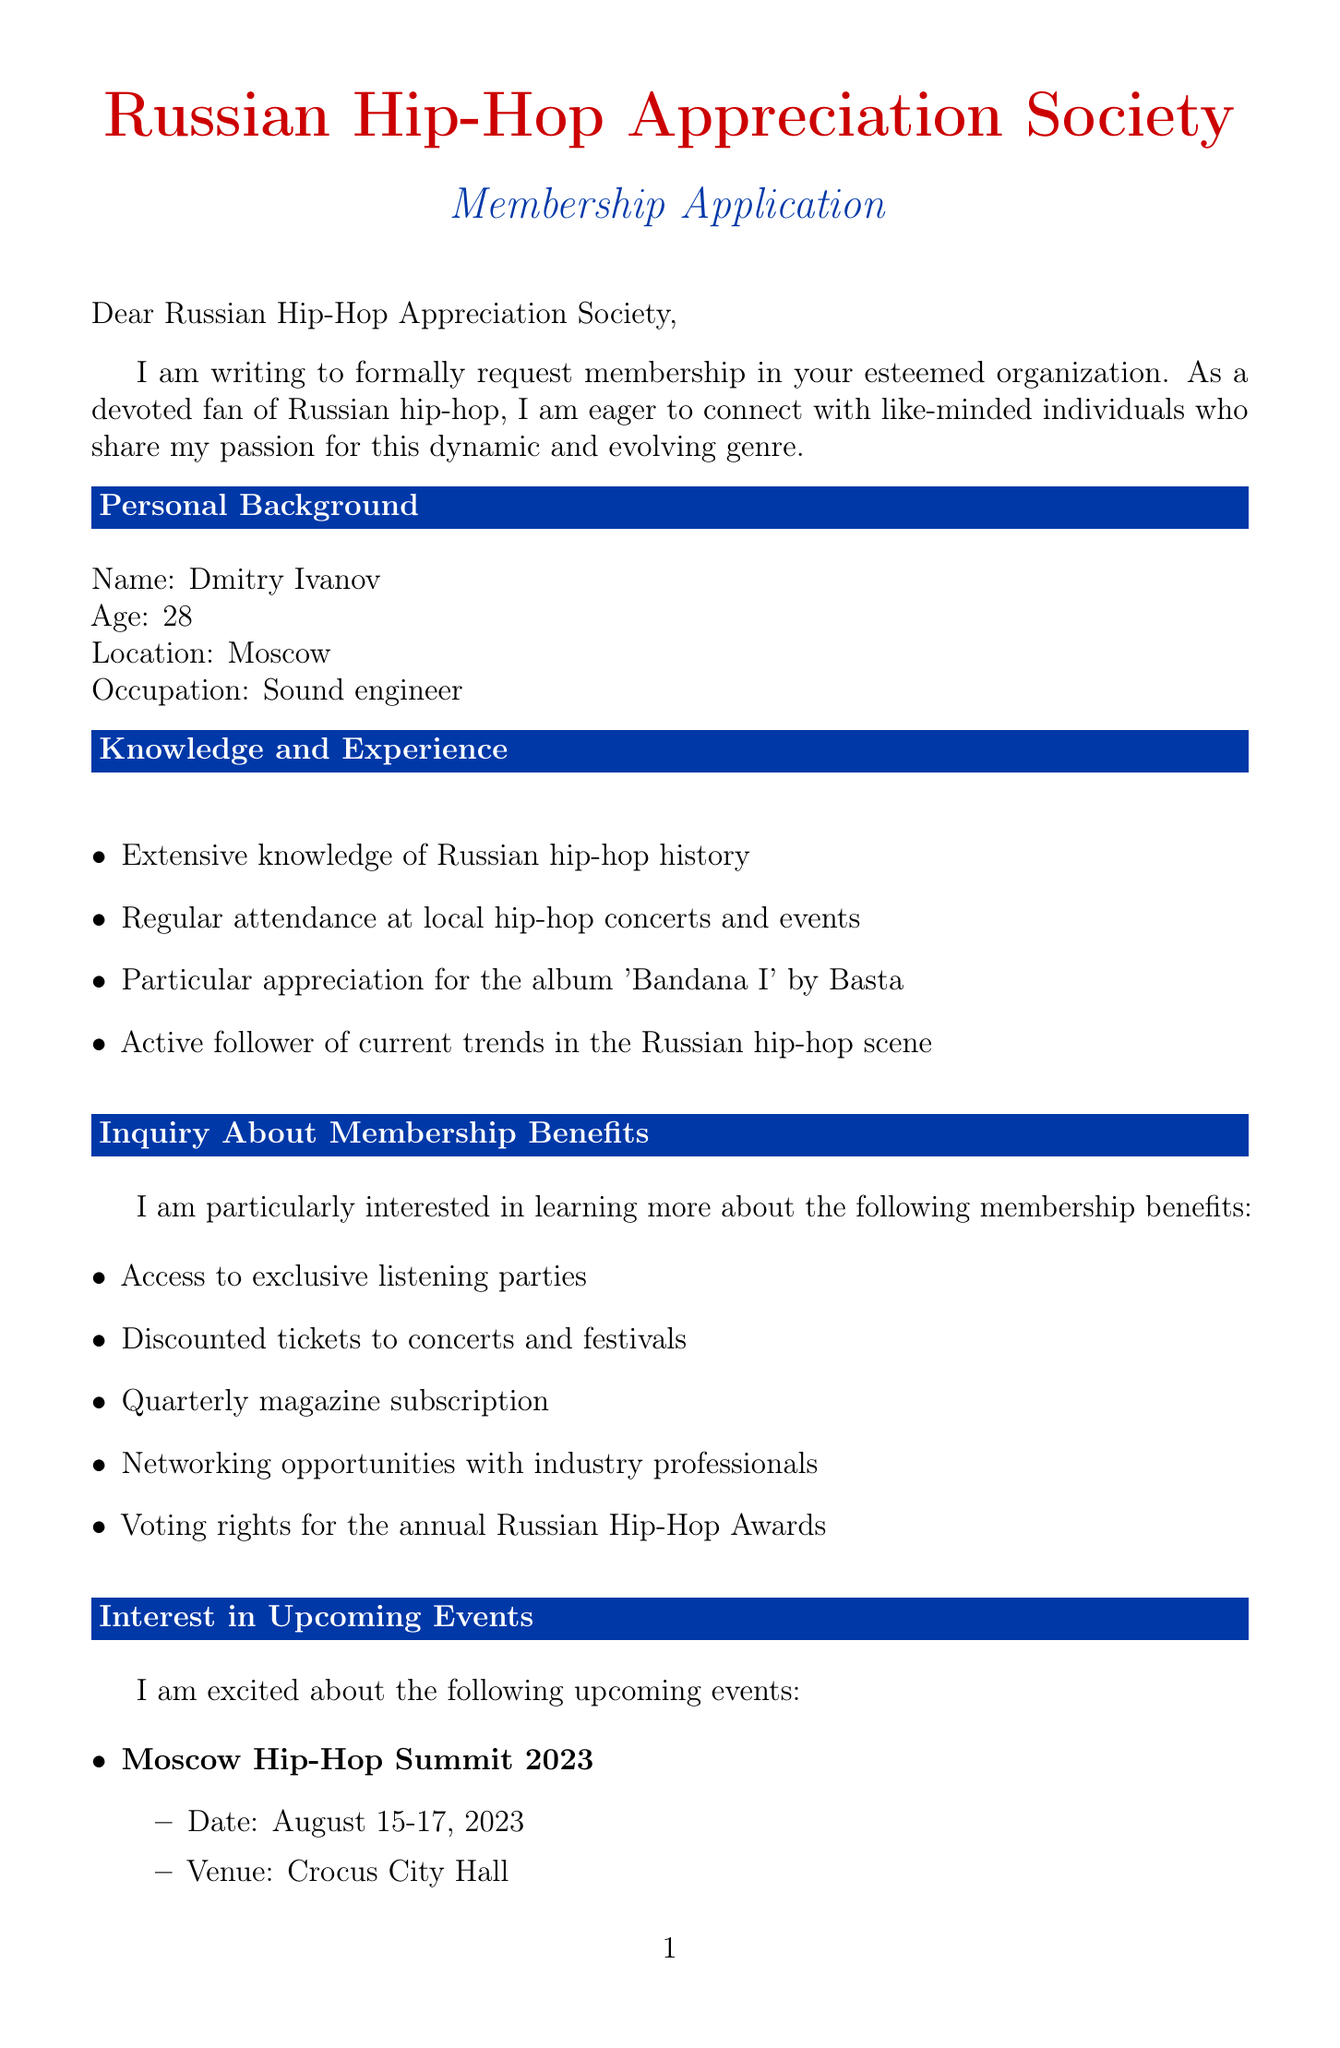What is the name of the applicant? The applicant's name is stated in the personal background section of the letter.
Answer: Dmitry Ivanov How old is Dmitry Ivanov? The age of the applicant is mentioned directly in the personal background section.
Answer: 28 What event is scheduled for August 15-17, 2023? The event details, including name and date, are provided in the upcoming events section.
Answer: Moscow Hip-Hop Summit 2023 Who are the headliners of the Moscow Hip-Hop Summit 2023? The headliners are listed under the specific event details in the document.
Answer: Scriptonite, Oxxxymiron, Miyagi & Andy Panda What is one benefit of membership mentioned? The document lists several benefits in the membership benefits section.
Answer: Access to exclusive listening parties What is the venue for the Underground Beats Workshop? The venue information is included with the event details in the document.
Answer: Artplay Design Center What is the profession of Dmitry Ivanov? The occupation of the applicant is explicitly stated in the personal background section.
Answer: Sound engineer What lecture series takes place every Tuesday in October 2023? The specific lecture series is mentioned in the upcoming events section of the document.
Answer: Russian Hip-Hop History Lecture Series What speaker is featured in the Russian Hip-Hop History Lecture Series? The name of the speaker is included in the details of the lecture series.
Answer: Professor Ivan Alexeyev 